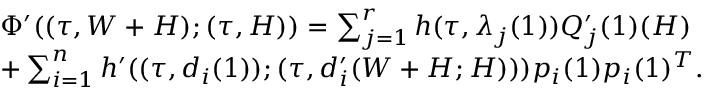Convert formula to latex. <formula><loc_0><loc_0><loc_500><loc_500>\begin{array} { r l } & { \, \Phi ^ { \prime } ( ( \tau , W + H ) ; ( \tau , H ) ) = \sum _ { j = 1 } ^ { r } h ( \tau , \lambda _ { j } ( 1 ) ) Q _ { j } ^ { \prime } ( 1 ) ( H ) } \\ & { \, + \sum _ { i = 1 } ^ { n } h ^ { \prime } ( ( \tau , d _ { i } ( 1 ) ) ; ( \tau , d _ { i } ^ { \prime } ( W + H ; H ) ) ) p _ { i } ( 1 ) p _ { i } ( 1 ) ^ { T } . } \end{array}</formula> 